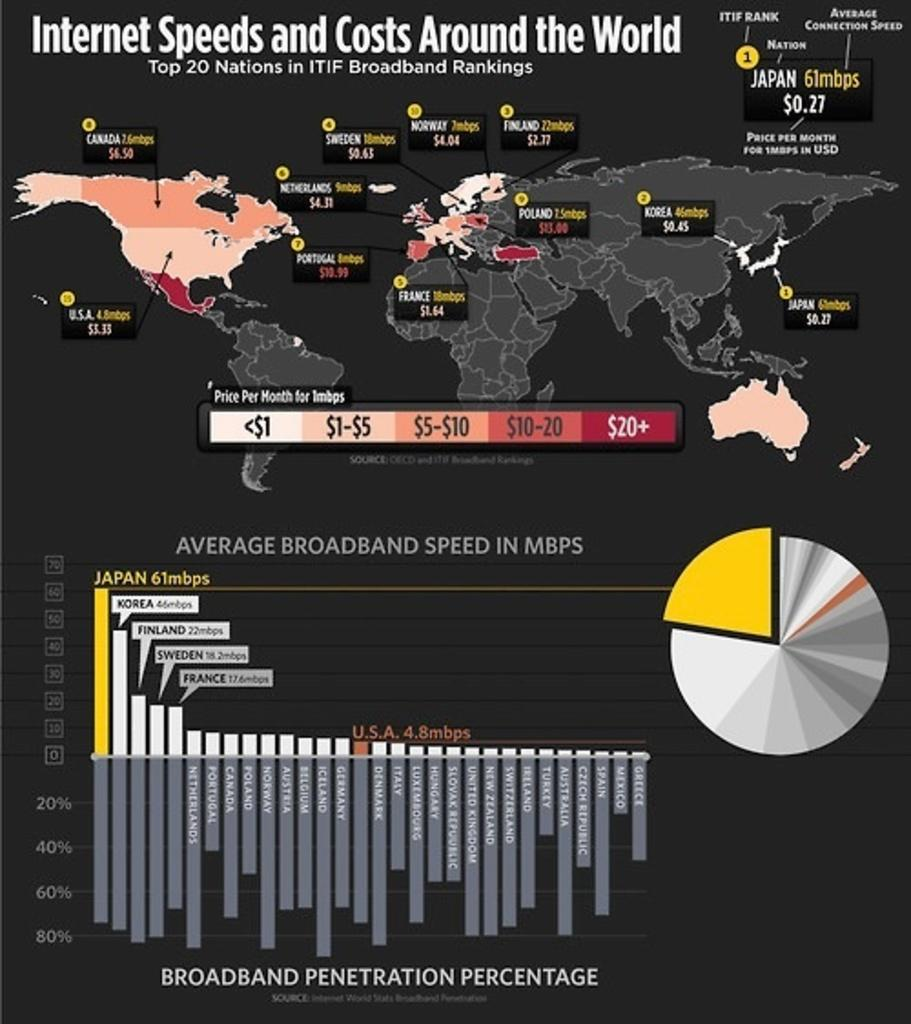<image>
Write a terse but informative summary of the picture. Comparison chart with various internet speeds and costs around the world. 